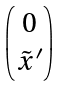Convert formula to latex. <formula><loc_0><loc_0><loc_500><loc_500>\begin{pmatrix} 0 \\ \tilde { x } ^ { \prime } \end{pmatrix}</formula> 